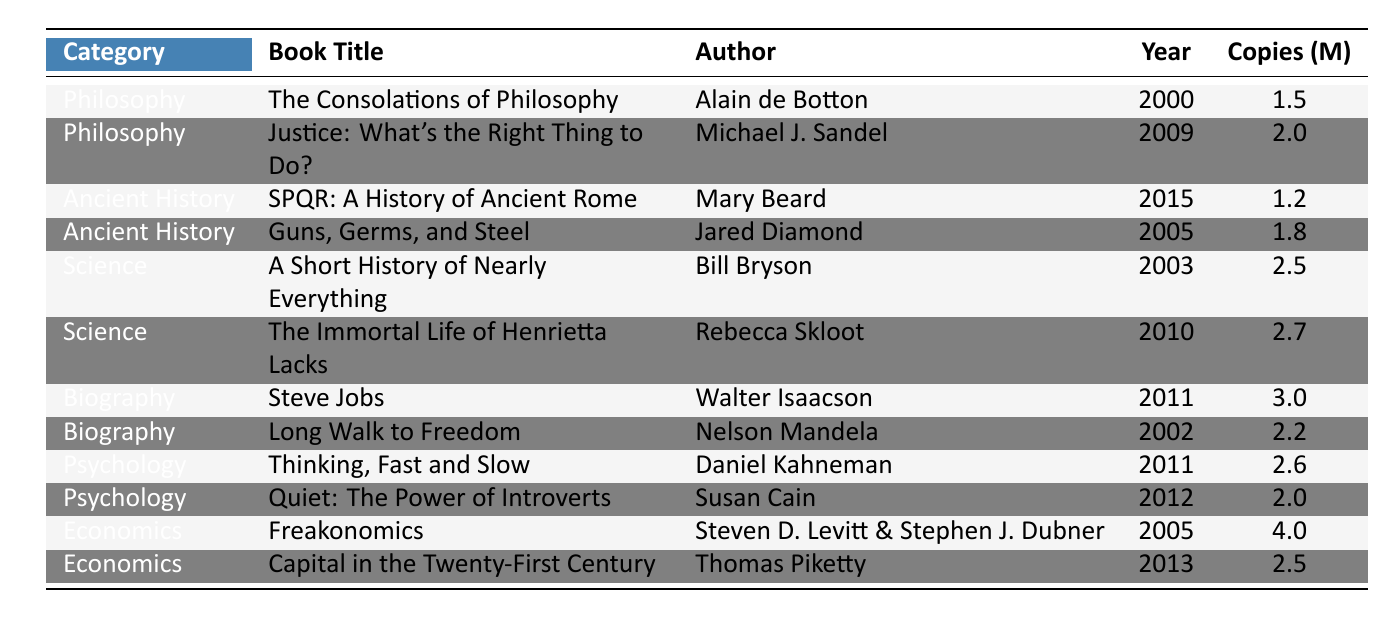What is the title of the bestselling non-fiction book in the Economics category? The Economics category has two books listed. Comparing their sales, "Freakonomics" with 4.0 million copies sold is higher than "Capital in the Twenty-First Century" with 2.5 million copies sold. Therefore, the title of the bestselling book in this category is "Freakonomics."
Answer: Freakonomics Which author wrote more than one bestselling non-fiction book? Reviewing the table, “Steven D. Levitt & Stephen J. Dubner” are identified as the authors of "Freakonomics," while other authors like Daniel Kahneman and Walter Isaacson each have one book in the list. Thus, Steven D. Levitt & Stephen J. Dubner is the only author with more than one book listed.
Answer: False What year was "The Immortal Life of Henrietta Lacks" published? The table indicates the publication year for "The Immortal Life of Henrietta Lacks" is directly listed as 2010.
Answer: 2010 What is the average number of copies sold across all books in the Psychology category? The Psychology category includes "Thinking, Fast and Slow" (2.6 million) and "Quiet: The Power of Introverts" (2.0 million). To find the average, sum these values: 2.6 + 2.0 = 4.6. Then divide by the number of books (2) to get 4.6/2 = 2.3 million.
Answer: 2.3 million Which book sold the least copies among the listed books? By examining the "Copies Sold" column, the data shows "SPQR: A History of Ancient Rome" with 1.2 million copies is the lowest. Thus, this book sold the least copies.
Answer: SPQR: A History of Ancient Rome What is the total number of copies sold of all the books in the biography category? The Biography category includes two books: "Steve Jobs" (3.0 million) and "Long Walk to Freedom" (2.2 million). Adding these together gives 3.0 + 2.2 = 5.2 million copies sold in total for this category.
Answer: 5.2 million Which category has the highest total sales and what is that total? The Economics category has the book "Freakonomics" (4.0 million) and "Capital in the Twenty-First Century" (2.5 million), totaling 6.5 million. Comparing this with other categories, none exceeds 6.5 million. Therefore, the Economics category has the highest sales.
Answer: Economics, 6.5 million Is "Justice: What's the Right Thing to Do?" the only book written by Michael J. Sandel? The information indicates that "Justice: What's the Right Thing to Do?" is the only entry for Michael J. Sandel, showing that he has not written any additional books listed in this table.
Answer: Yes How many copies did "Thinking, Fast and Slow" sell compared to "Guns, Germs, and Steel"? "Thinking, Fast and Slow" sold 2.6 million copies, while "Guns, Germs, and Steel" sold 1.8 million copies. To find the difference, subtract: 2.6 - 1.8 = 0.8 million. So, "Thinking, Fast and Slow" sold 0.8 million more copies.
Answer: 0.8 million Which books were published before 2010? Checking the years published, the books released before 2010 include "The Consolations of Philosophy" (2000), "Long Walk to Freedom" (2002), "A Short History of Nearly Everything" (2003), "Guns, Germs, and Steel" (2005), and "Freakonomics" (2005). Thus, five books were published before 2010.
Answer: 5 books What percentage of total copies sold does "Steve Jobs" represent? First, find the total copies sold across all books: 1.5 + 2.0 + 1.2 + 1.8 + 2.5 + 2.7 + 3.0 + 2.2 + 2.6 + 2.0 + 4.0 + 2.5 = 24.0 million. Now, "Steve Jobs" sold 3.0 million copies. The percentage is (3.0/24.0) * 100 = 12.5%.
Answer: 12.5% 